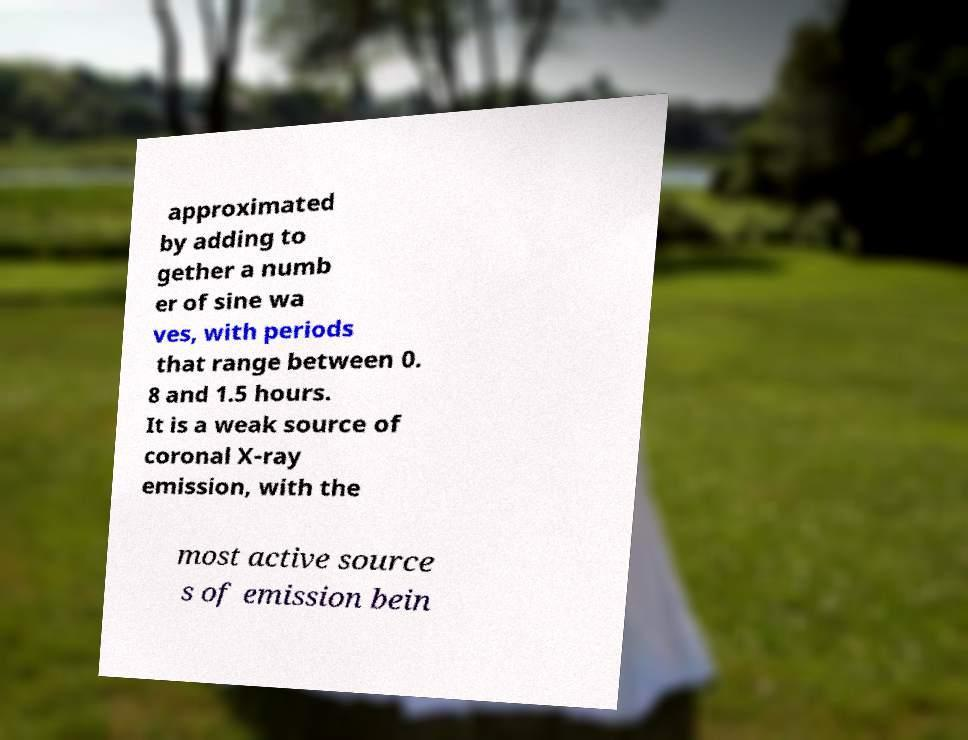Could you assist in decoding the text presented in this image and type it out clearly? approximated by adding to gether a numb er of sine wa ves, with periods that range between 0. 8 and 1.5 hours. It is a weak source of coronal X-ray emission, with the most active source s of emission bein 